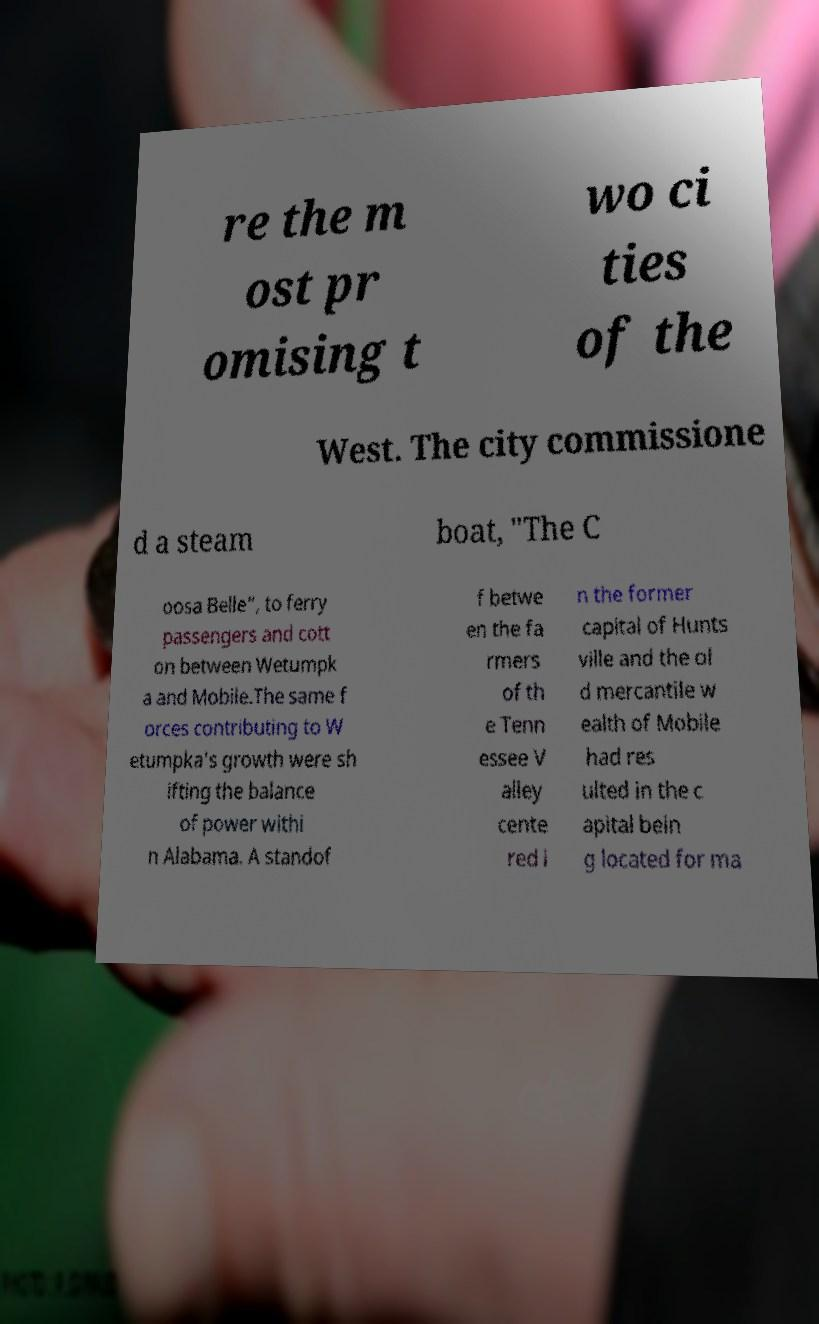Could you assist in decoding the text presented in this image and type it out clearly? re the m ost pr omising t wo ci ties of the West. The city commissione d a steam boat, "The C oosa Belle", to ferry passengers and cott on between Wetumpk a and Mobile.The same f orces contributing to W etumpka's growth were sh ifting the balance of power withi n Alabama. A standof f betwe en the fa rmers of th e Tenn essee V alley cente red i n the former capital of Hunts ville and the ol d mercantile w ealth of Mobile had res ulted in the c apital bein g located for ma 